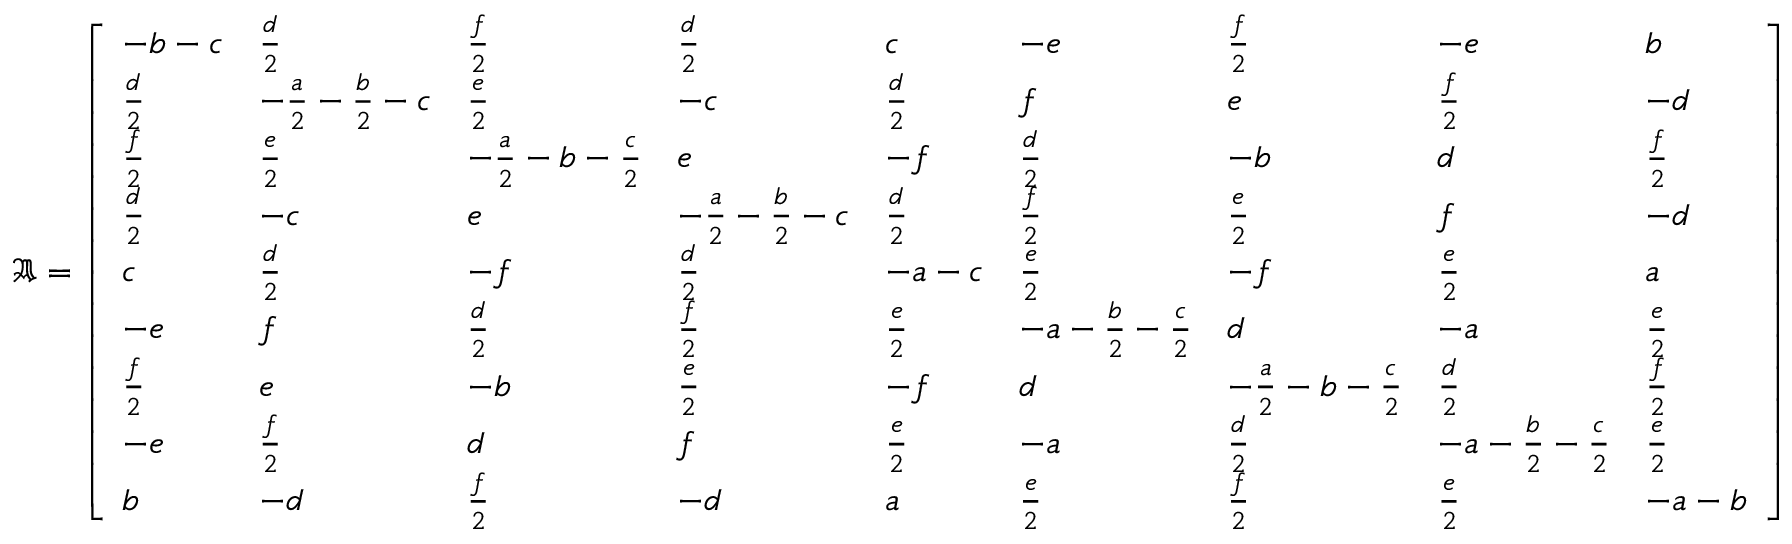Convert formula to latex. <formula><loc_0><loc_0><loc_500><loc_500>\mathfrak { A } = \left [ \begin{array} { l l l l l l l l l } { - b - c } & { \frac { d } { 2 } } & { \frac { f } { 2 } } & { \frac { d } { 2 } } & { c } & { - e } & { \frac { f } { 2 } } & { - e } & { b } \\ { \frac { d } { 2 } } & { - \frac { a } { 2 } - \frac { b } { 2 } - c } & { \frac { e } { 2 } } & { - c } & { \frac { d } { 2 } } & { f } & { e } & { \frac { f } { 2 } } & { - d } \\ { \frac { f } { 2 } } & { \frac { e } { 2 } } & { - \frac { a } { 2 } - b - \frac { c } { 2 } } & { e } & { - f } & { \frac { d } { 2 } } & { - b } & { d } & { \frac { f } { 2 } } \\ { \frac { d } { 2 } } & { - c } & { e } & { - \frac { a } { 2 } - \frac { b } { 2 } - c } & { \frac { d } { 2 } } & { \frac { f } { 2 } } & { \frac { e } { 2 } } & { f } & { - d } \\ { c } & { \frac { d } { 2 } } & { - f } & { \frac { d } { 2 } } & { - a - c } & { \frac { e } { 2 } } & { - f } & { \frac { e } { 2 } } & { a } \\ { - e } & { f } & { \frac { d } { 2 } } & { \frac { f } { 2 } } & { \frac { e } { 2 } } & { - a - \frac { b } { 2 } - \frac { c } { 2 } } & { d } & { - a } & { \frac { e } { 2 } } \\ { \frac { f } { 2 } } & { e } & { - b } & { \frac { e } { 2 } } & { - f } & { d } & { - \frac { a } { 2 } - b - \frac { c } { 2 } } & { \frac { d } { 2 } } & { \frac { f } { 2 } } \\ { - e } & { \frac { f } { 2 } } & { d } & { f } & { \frac { e } { 2 } } & { - a } & { \frac { d } { 2 } } & { - a - \frac { b } { 2 } - \frac { c } { 2 } } & { \frac { e } { 2 } } \\ { b } & { - d } & { \frac { f } { 2 } } & { - d } & { a } & { \frac { e } { 2 } } & { \frac { f } { 2 } } & { \frac { e } { 2 } } & { - a - b } \end{array} \right ]</formula> 